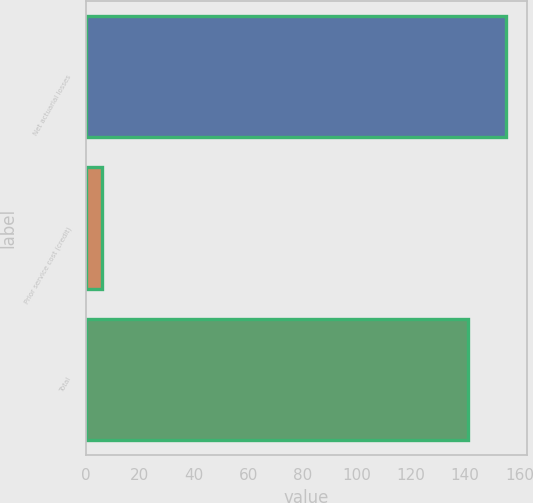Convert chart to OTSL. <chart><loc_0><loc_0><loc_500><loc_500><bar_chart><fcel>Net actuarial losses<fcel>Prior service cost (credit)<fcel>Total<nl><fcel>155.1<fcel>6<fcel>141<nl></chart> 